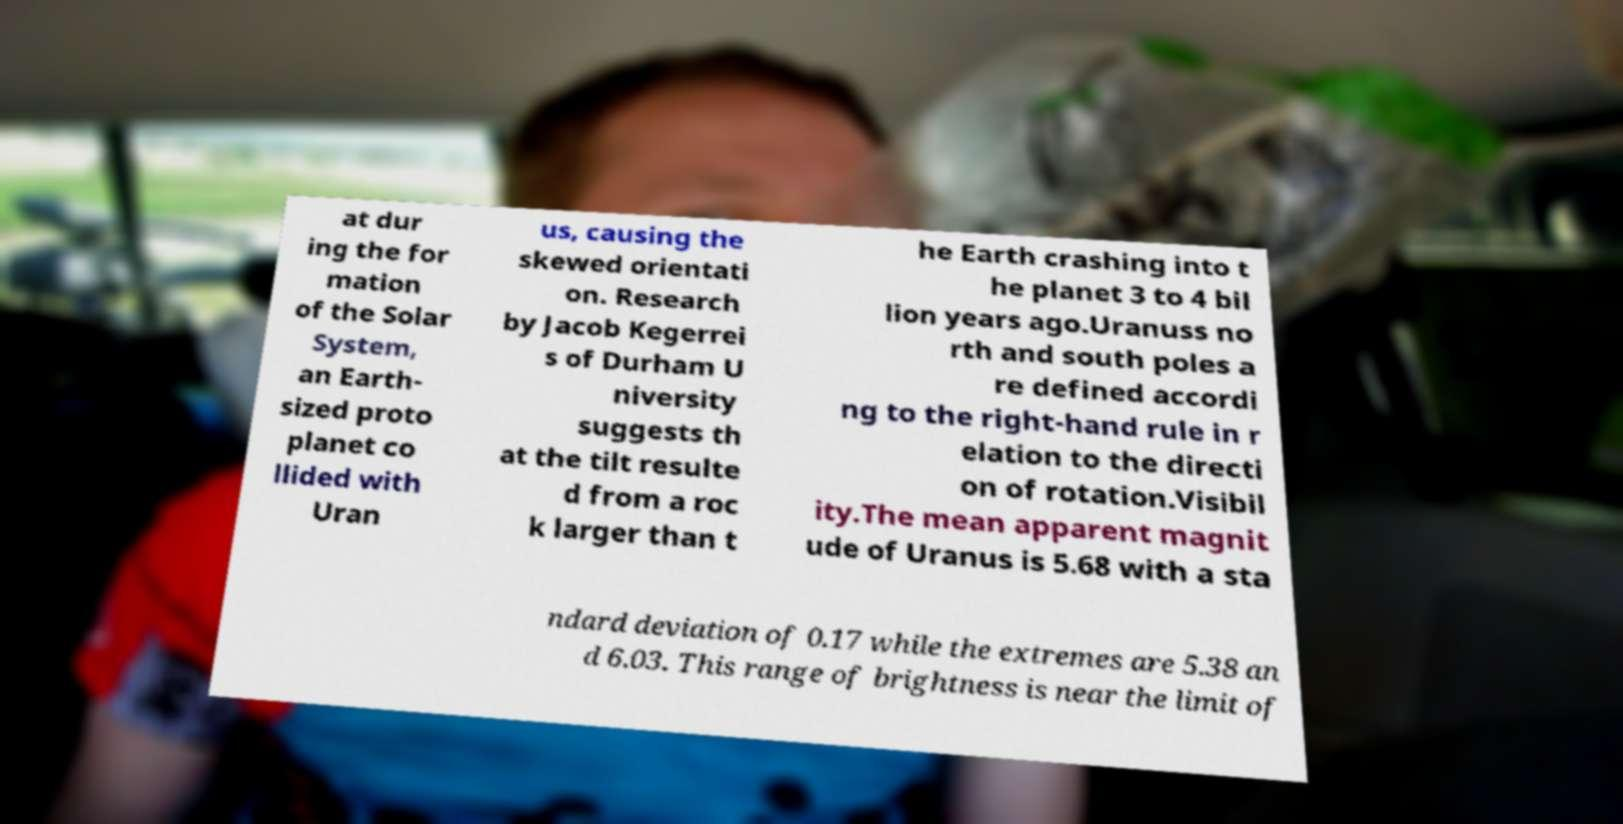Could you assist in decoding the text presented in this image and type it out clearly? at dur ing the for mation of the Solar System, an Earth- sized proto planet co llided with Uran us, causing the skewed orientati on. Research by Jacob Kegerrei s of Durham U niversity suggests th at the tilt resulte d from a roc k larger than t he Earth crashing into t he planet 3 to 4 bil lion years ago.Uranuss no rth and south poles a re defined accordi ng to the right-hand rule in r elation to the directi on of rotation.Visibil ity.The mean apparent magnit ude of Uranus is 5.68 with a sta ndard deviation of 0.17 while the extremes are 5.38 an d 6.03. This range of brightness is near the limit of 